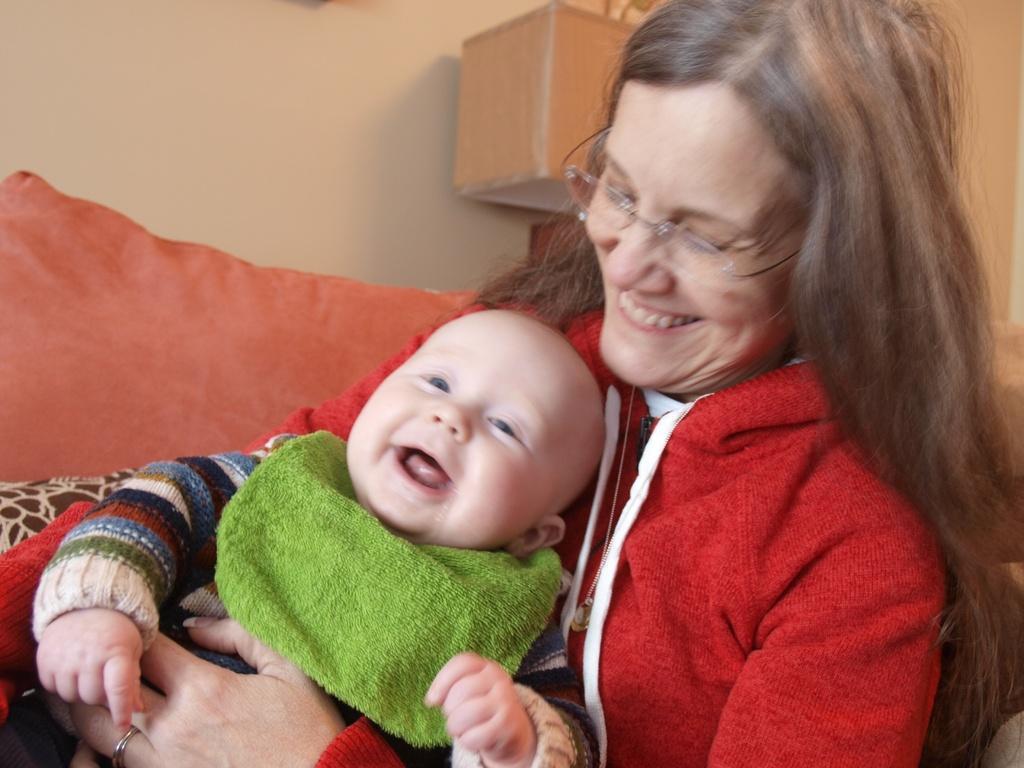How would you summarize this image in a sentence or two? In the center of the image we can see a lady is sitting on a couch and wearing coat, spectacles and smiling and holding a kid. In the background of the image we can see the wall, wooden box. On the left side of the image we can see a pillow. 